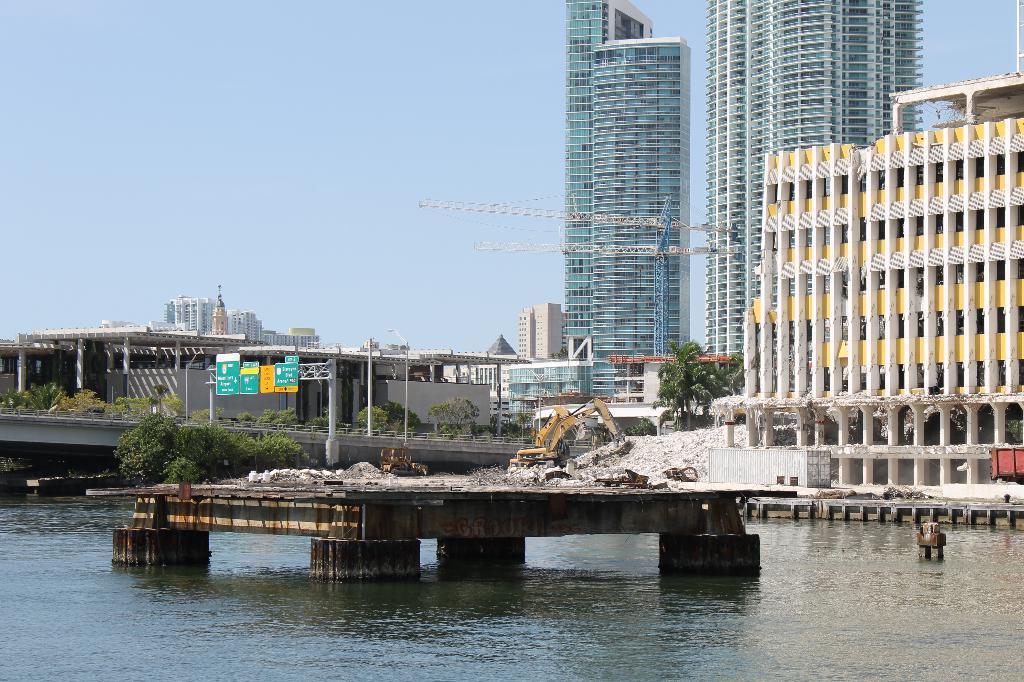In one or two sentences, can you explain what this image depicts? In this image there is water. There is a stage in the middle of the water. There are trees. There are tall buildings. There is a proclainer. There is a sky. 